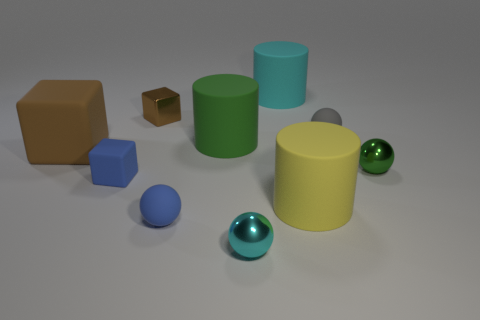How big is the matte cylinder in front of the large brown rubber cube?
Offer a terse response. Large. Is the number of tiny blue spheres that are right of the cyan shiny object the same as the number of gray matte objects?
Ensure brevity in your answer.  No. Is there a tiny metallic object of the same shape as the brown rubber object?
Give a very brief answer. Yes. The thing that is both to the left of the cyan ball and behind the tiny gray sphere has what shape?
Keep it short and to the point. Cube. Does the tiny cyan thing have the same material as the cyan thing behind the tiny gray matte object?
Your response must be concise. No. There is a large cyan rubber cylinder; are there any green rubber things behind it?
Offer a terse response. No. What number of objects are either large yellow rubber cylinders or big rubber cylinders that are in front of the small brown block?
Offer a very short reply. 2. The large object that is behind the small matte thing on the right side of the yellow rubber thing is what color?
Provide a succinct answer. Cyan. What number of other objects are the same material as the blue ball?
Keep it short and to the point. 6. What number of matte objects are balls or gray balls?
Your answer should be very brief. 2. 